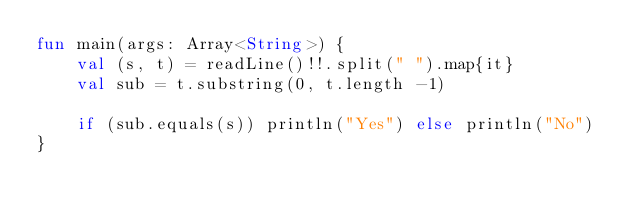Convert code to text. <code><loc_0><loc_0><loc_500><loc_500><_Kotlin_>fun main(args: Array<String>) {
    val (s, t) = readLine()!!.split(" ").map{it}
    val sub = t.substring(0, t.length -1)
    
    if (sub.equals(s)) println("Yes") else println("No")
}</code> 